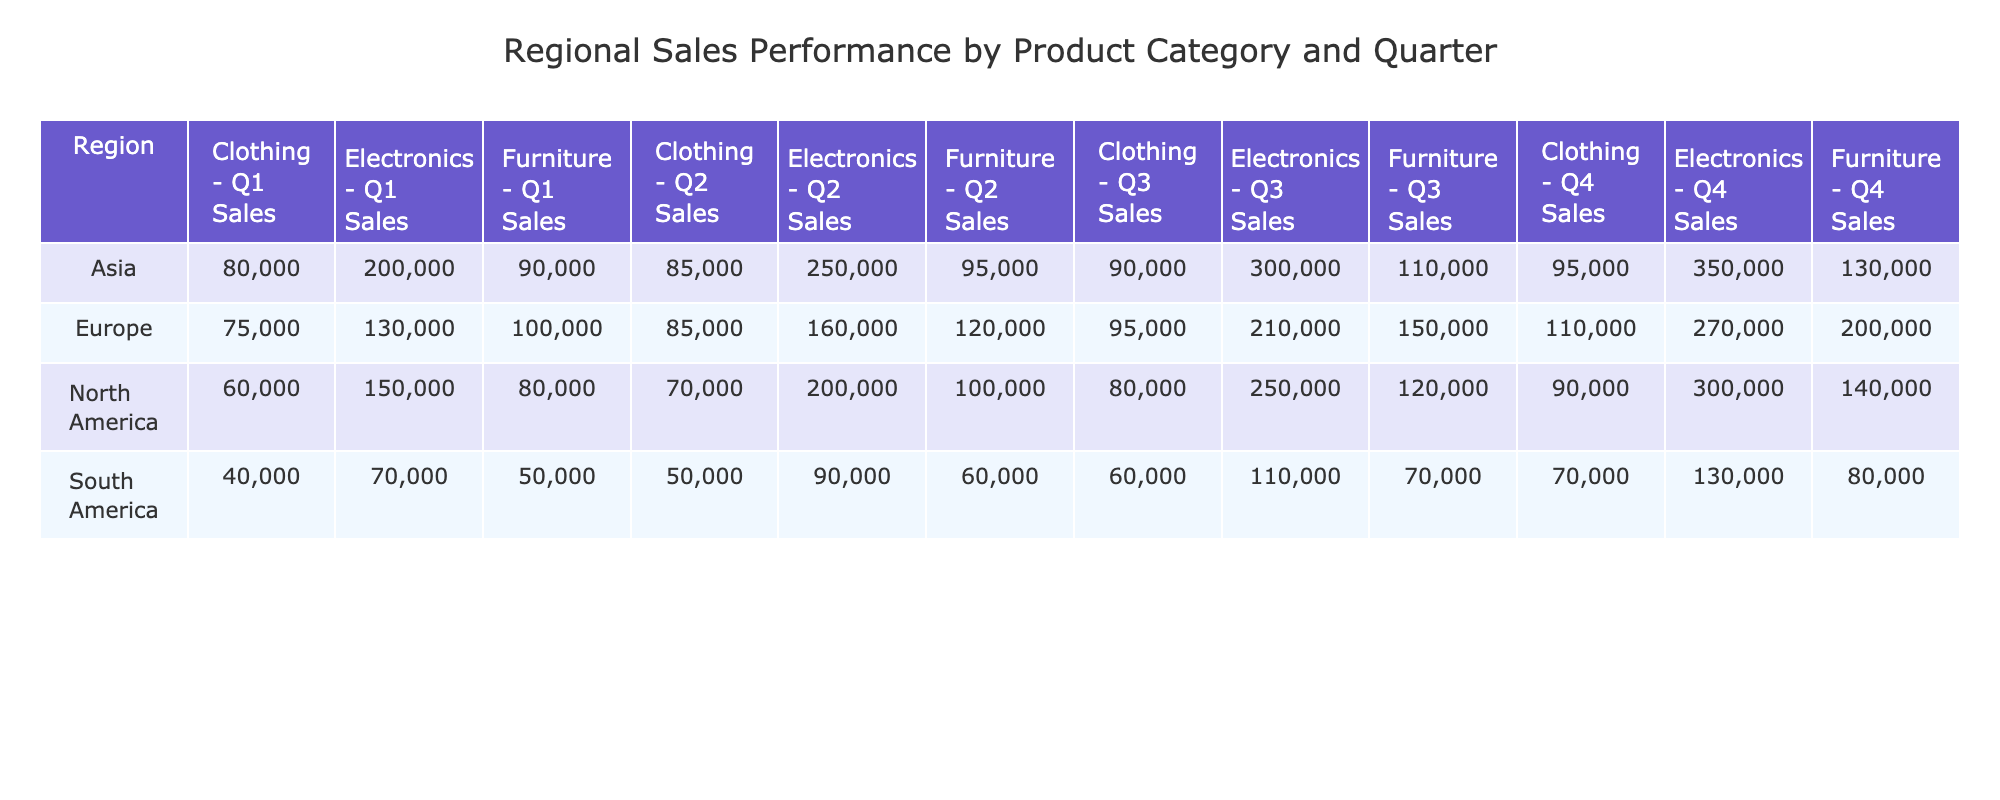What is the total sales for Electronics in North America across all quarters? To find the total sales for Electronics in North America, add the sales for each quarter: 150000 (Q1) + 200000 (Q2) + 250000 (Q3) + 300000 (Q4) = 900000.
Answer: 900000 Which product category had the highest sales in Europe during Q3? In the table, the sales for Q3 in Europe are: Electronics: 210000, Furniture: 150000, Clothing: 95000. The highest value is 210000 for Electronics.
Answer: Electronics What was the combined sales of Clothing in Asia for all quarters? The sales for Clothing in Asia are: 80000 (Q1) + 85000 (Q2) + 90000 (Q3) + 95000 (Q4) = 350000. So, the combined sales equals 350000.
Answer: 350000 Did South America sell more Furniture than Clothing in Q4? For Q4, South America sold 80000 in Furniture and 70000 in Clothing. Since 80000 is greater than 70000, the answer is yes.
Answer: Yes What is the average sales amount for Furniture across all regions in Q2? The Q2 sales for Furniture are: North America: 100000, Europe: 120000, Asia: 95000, South America: 60000. Their sum is 100000 + 120000 + 95000 + 60000 = 410000. There are 4 regions, so the average is 410000 / 4 = 102500.
Answer: 102500 Which region had the highest sales in Q1 across all product categories? From the Q1 sales data, compare: North America: 150000 + 80000 + 60000 = 290000, Europe: 130000 + 100000 + 75000 = 305000, Asia: 200000 + 90000 + 80000 = 370000, South America: 70000 + 50000 + 40000 = 160000. The highest is Asia with 370000.
Answer: Asia What is the difference in Q4 sales between Electronics in Asia and South America? Q4 sales for Electronics are: Asia: 350000, South America: 130000. The difference is 350000 - 130000 = 220000.
Answer: 220000 Is the total sales for Clothing in North America greater than 300000? The total sales for Clothing in North America are: 60000 (Q1) + 70000 (Q2) + 80000 (Q3) + 90000 (Q4) = 310000. Since 310000 is greater than 300000, the answer is yes.
Answer: Yes What was the total sales for Furniture in Europe in Q3 and Q4 combined? For Furniture in Europe, Q3 sales are 150000 and Q4 sales are 200000. Combining these gives 150000 + 200000 = 350000 for Q3 and Q4.
Answer: 350000 